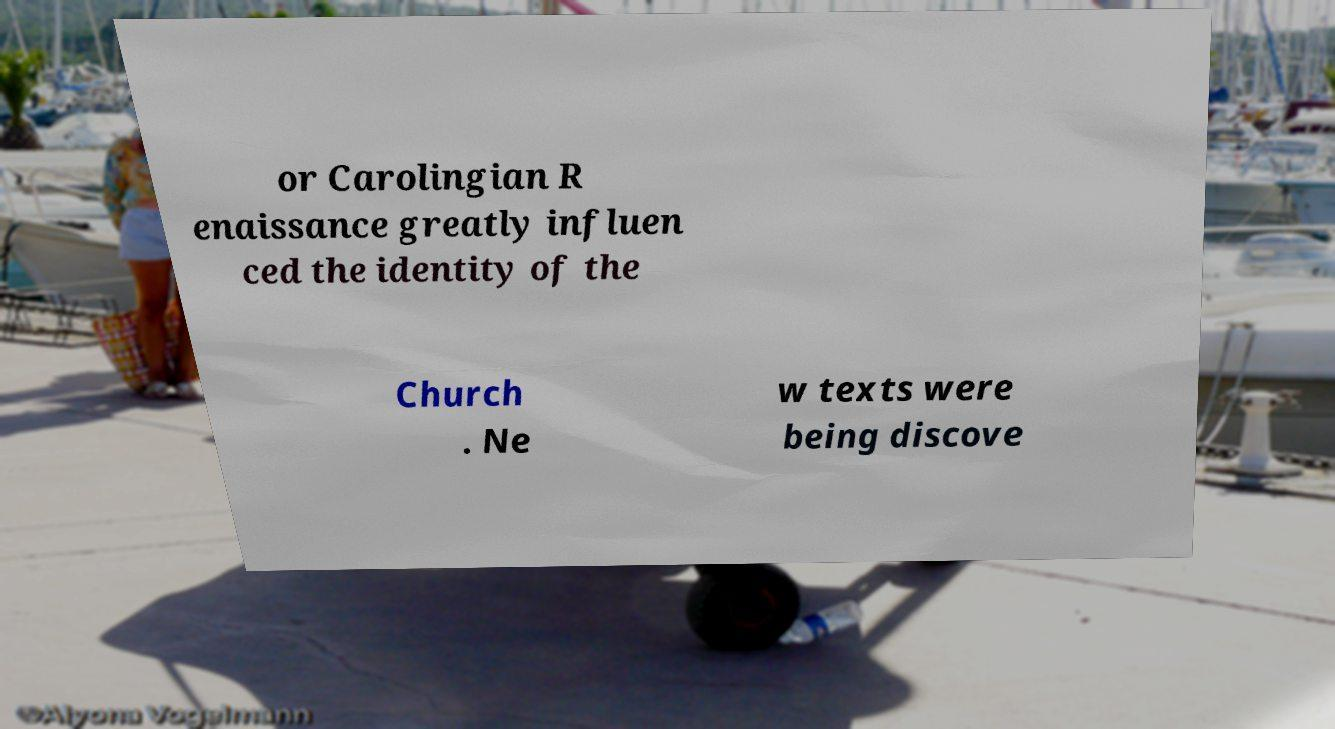I need the written content from this picture converted into text. Can you do that? or Carolingian R enaissance greatly influen ced the identity of the Church . Ne w texts were being discove 